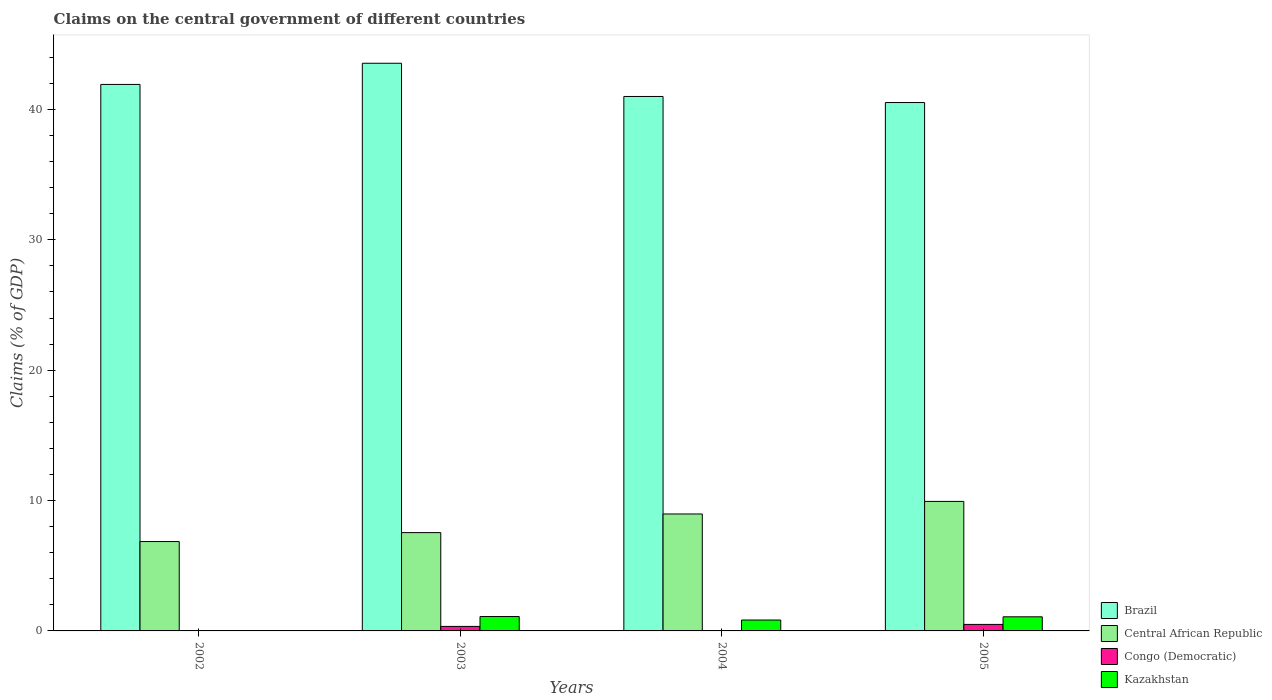How many groups of bars are there?
Your answer should be very brief. 4. Are the number of bars per tick equal to the number of legend labels?
Make the answer very short. No. How many bars are there on the 3rd tick from the right?
Provide a short and direct response. 4. What is the percentage of GDP claimed on the central government in Brazil in 2005?
Offer a very short reply. 40.53. Across all years, what is the maximum percentage of GDP claimed on the central government in Central African Republic?
Your response must be concise. 9.93. Across all years, what is the minimum percentage of GDP claimed on the central government in Central African Republic?
Keep it short and to the point. 6.86. In which year was the percentage of GDP claimed on the central government in Congo (Democratic) maximum?
Provide a succinct answer. 2005. What is the total percentage of GDP claimed on the central government in Central African Republic in the graph?
Give a very brief answer. 33.3. What is the difference between the percentage of GDP claimed on the central government in Brazil in 2002 and that in 2005?
Your answer should be very brief. 1.39. What is the difference between the percentage of GDP claimed on the central government in Congo (Democratic) in 2002 and the percentage of GDP claimed on the central government in Central African Republic in 2004?
Provide a short and direct response. -8.97. What is the average percentage of GDP claimed on the central government in Kazakhstan per year?
Give a very brief answer. 0.76. In the year 2005, what is the difference between the percentage of GDP claimed on the central government in Congo (Democratic) and percentage of GDP claimed on the central government in Kazakhstan?
Provide a succinct answer. -0.58. What is the ratio of the percentage of GDP claimed on the central government in Kazakhstan in 2003 to that in 2005?
Ensure brevity in your answer.  1.02. What is the difference between the highest and the second highest percentage of GDP claimed on the central government in Brazil?
Offer a very short reply. 1.62. What is the difference between the highest and the lowest percentage of GDP claimed on the central government in Brazil?
Your answer should be compact. 3.01. In how many years, is the percentage of GDP claimed on the central government in Congo (Democratic) greater than the average percentage of GDP claimed on the central government in Congo (Democratic) taken over all years?
Your response must be concise. 2. Is the sum of the percentage of GDP claimed on the central government in Central African Republic in 2003 and 2005 greater than the maximum percentage of GDP claimed on the central government in Congo (Democratic) across all years?
Offer a very short reply. Yes. Is it the case that in every year, the sum of the percentage of GDP claimed on the central government in Brazil and percentage of GDP claimed on the central government in Kazakhstan is greater than the sum of percentage of GDP claimed on the central government in Congo (Democratic) and percentage of GDP claimed on the central government in Central African Republic?
Your response must be concise. Yes. Is it the case that in every year, the sum of the percentage of GDP claimed on the central government in Central African Republic and percentage of GDP claimed on the central government in Congo (Democratic) is greater than the percentage of GDP claimed on the central government in Kazakhstan?
Your response must be concise. Yes. How many years are there in the graph?
Offer a terse response. 4. What is the difference between two consecutive major ticks on the Y-axis?
Provide a short and direct response. 10. Does the graph contain any zero values?
Provide a succinct answer. Yes. How many legend labels are there?
Your response must be concise. 4. How are the legend labels stacked?
Provide a short and direct response. Vertical. What is the title of the graph?
Offer a very short reply. Claims on the central government of different countries. Does "Samoa" appear as one of the legend labels in the graph?
Ensure brevity in your answer.  No. What is the label or title of the X-axis?
Your response must be concise. Years. What is the label or title of the Y-axis?
Your answer should be very brief. Claims (% of GDP). What is the Claims (% of GDP) of Brazil in 2002?
Keep it short and to the point. 41.92. What is the Claims (% of GDP) of Central African Republic in 2002?
Your answer should be very brief. 6.86. What is the Claims (% of GDP) of Kazakhstan in 2002?
Provide a short and direct response. 0. What is the Claims (% of GDP) in Brazil in 2003?
Make the answer very short. 43.54. What is the Claims (% of GDP) of Central African Republic in 2003?
Offer a very short reply. 7.54. What is the Claims (% of GDP) in Congo (Democratic) in 2003?
Offer a terse response. 0.35. What is the Claims (% of GDP) of Kazakhstan in 2003?
Your answer should be compact. 1.1. What is the Claims (% of GDP) in Brazil in 2004?
Offer a very short reply. 40.99. What is the Claims (% of GDP) of Central African Republic in 2004?
Offer a very short reply. 8.97. What is the Claims (% of GDP) of Congo (Democratic) in 2004?
Give a very brief answer. 0. What is the Claims (% of GDP) in Kazakhstan in 2004?
Your answer should be compact. 0.84. What is the Claims (% of GDP) in Brazil in 2005?
Ensure brevity in your answer.  40.53. What is the Claims (% of GDP) of Central African Republic in 2005?
Ensure brevity in your answer.  9.93. What is the Claims (% of GDP) in Congo (Democratic) in 2005?
Give a very brief answer. 0.5. What is the Claims (% of GDP) in Kazakhstan in 2005?
Your answer should be compact. 1.08. Across all years, what is the maximum Claims (% of GDP) in Brazil?
Your answer should be compact. 43.54. Across all years, what is the maximum Claims (% of GDP) in Central African Republic?
Provide a short and direct response. 9.93. Across all years, what is the maximum Claims (% of GDP) of Congo (Democratic)?
Your answer should be very brief. 0.5. Across all years, what is the maximum Claims (% of GDP) in Kazakhstan?
Make the answer very short. 1.1. Across all years, what is the minimum Claims (% of GDP) of Brazil?
Your answer should be very brief. 40.53. Across all years, what is the minimum Claims (% of GDP) of Central African Republic?
Offer a very short reply. 6.86. Across all years, what is the minimum Claims (% of GDP) in Kazakhstan?
Ensure brevity in your answer.  0. What is the total Claims (% of GDP) of Brazil in the graph?
Ensure brevity in your answer.  166.98. What is the total Claims (% of GDP) of Central African Republic in the graph?
Make the answer very short. 33.3. What is the total Claims (% of GDP) in Congo (Democratic) in the graph?
Give a very brief answer. 0.85. What is the total Claims (% of GDP) of Kazakhstan in the graph?
Offer a very short reply. 3.02. What is the difference between the Claims (% of GDP) in Brazil in 2002 and that in 2003?
Provide a succinct answer. -1.62. What is the difference between the Claims (% of GDP) of Central African Republic in 2002 and that in 2003?
Provide a short and direct response. -0.68. What is the difference between the Claims (% of GDP) of Brazil in 2002 and that in 2004?
Ensure brevity in your answer.  0.92. What is the difference between the Claims (% of GDP) in Central African Republic in 2002 and that in 2004?
Your answer should be compact. -2.12. What is the difference between the Claims (% of GDP) in Brazil in 2002 and that in 2005?
Ensure brevity in your answer.  1.39. What is the difference between the Claims (% of GDP) of Central African Republic in 2002 and that in 2005?
Give a very brief answer. -3.08. What is the difference between the Claims (% of GDP) in Brazil in 2003 and that in 2004?
Make the answer very short. 2.55. What is the difference between the Claims (% of GDP) in Central African Republic in 2003 and that in 2004?
Give a very brief answer. -1.43. What is the difference between the Claims (% of GDP) in Kazakhstan in 2003 and that in 2004?
Offer a terse response. 0.27. What is the difference between the Claims (% of GDP) in Brazil in 2003 and that in 2005?
Your answer should be compact. 3.01. What is the difference between the Claims (% of GDP) of Central African Republic in 2003 and that in 2005?
Keep it short and to the point. -2.39. What is the difference between the Claims (% of GDP) in Congo (Democratic) in 2003 and that in 2005?
Provide a succinct answer. -0.15. What is the difference between the Claims (% of GDP) of Kazakhstan in 2003 and that in 2005?
Your response must be concise. 0.02. What is the difference between the Claims (% of GDP) of Brazil in 2004 and that in 2005?
Your answer should be very brief. 0.47. What is the difference between the Claims (% of GDP) of Central African Republic in 2004 and that in 2005?
Keep it short and to the point. -0.96. What is the difference between the Claims (% of GDP) of Kazakhstan in 2004 and that in 2005?
Provide a succinct answer. -0.25. What is the difference between the Claims (% of GDP) in Brazil in 2002 and the Claims (% of GDP) in Central African Republic in 2003?
Keep it short and to the point. 34.38. What is the difference between the Claims (% of GDP) of Brazil in 2002 and the Claims (% of GDP) of Congo (Democratic) in 2003?
Provide a short and direct response. 41.57. What is the difference between the Claims (% of GDP) of Brazil in 2002 and the Claims (% of GDP) of Kazakhstan in 2003?
Give a very brief answer. 40.82. What is the difference between the Claims (% of GDP) of Central African Republic in 2002 and the Claims (% of GDP) of Congo (Democratic) in 2003?
Make the answer very short. 6.51. What is the difference between the Claims (% of GDP) in Central African Republic in 2002 and the Claims (% of GDP) in Kazakhstan in 2003?
Give a very brief answer. 5.75. What is the difference between the Claims (% of GDP) of Brazil in 2002 and the Claims (% of GDP) of Central African Republic in 2004?
Give a very brief answer. 32.95. What is the difference between the Claims (% of GDP) in Brazil in 2002 and the Claims (% of GDP) in Kazakhstan in 2004?
Your answer should be compact. 41.08. What is the difference between the Claims (% of GDP) in Central African Republic in 2002 and the Claims (% of GDP) in Kazakhstan in 2004?
Make the answer very short. 6.02. What is the difference between the Claims (% of GDP) of Brazil in 2002 and the Claims (% of GDP) of Central African Republic in 2005?
Give a very brief answer. 31.98. What is the difference between the Claims (% of GDP) of Brazil in 2002 and the Claims (% of GDP) of Congo (Democratic) in 2005?
Offer a terse response. 41.42. What is the difference between the Claims (% of GDP) of Brazil in 2002 and the Claims (% of GDP) of Kazakhstan in 2005?
Your answer should be compact. 40.84. What is the difference between the Claims (% of GDP) in Central African Republic in 2002 and the Claims (% of GDP) in Congo (Democratic) in 2005?
Offer a very short reply. 6.36. What is the difference between the Claims (% of GDP) in Central African Republic in 2002 and the Claims (% of GDP) in Kazakhstan in 2005?
Your answer should be compact. 5.77. What is the difference between the Claims (% of GDP) in Brazil in 2003 and the Claims (% of GDP) in Central African Republic in 2004?
Your answer should be very brief. 34.57. What is the difference between the Claims (% of GDP) of Brazil in 2003 and the Claims (% of GDP) of Kazakhstan in 2004?
Your answer should be very brief. 42.71. What is the difference between the Claims (% of GDP) of Central African Republic in 2003 and the Claims (% of GDP) of Kazakhstan in 2004?
Offer a very short reply. 6.7. What is the difference between the Claims (% of GDP) in Congo (Democratic) in 2003 and the Claims (% of GDP) in Kazakhstan in 2004?
Ensure brevity in your answer.  -0.49. What is the difference between the Claims (% of GDP) in Brazil in 2003 and the Claims (% of GDP) in Central African Republic in 2005?
Your response must be concise. 33.61. What is the difference between the Claims (% of GDP) of Brazil in 2003 and the Claims (% of GDP) of Congo (Democratic) in 2005?
Offer a terse response. 43.04. What is the difference between the Claims (% of GDP) in Brazil in 2003 and the Claims (% of GDP) in Kazakhstan in 2005?
Keep it short and to the point. 42.46. What is the difference between the Claims (% of GDP) of Central African Republic in 2003 and the Claims (% of GDP) of Congo (Democratic) in 2005?
Provide a succinct answer. 7.04. What is the difference between the Claims (% of GDP) of Central African Republic in 2003 and the Claims (% of GDP) of Kazakhstan in 2005?
Offer a very short reply. 6.46. What is the difference between the Claims (% of GDP) of Congo (Democratic) in 2003 and the Claims (% of GDP) of Kazakhstan in 2005?
Offer a very short reply. -0.74. What is the difference between the Claims (% of GDP) in Brazil in 2004 and the Claims (% of GDP) in Central African Republic in 2005?
Ensure brevity in your answer.  31.06. What is the difference between the Claims (% of GDP) in Brazil in 2004 and the Claims (% of GDP) in Congo (Democratic) in 2005?
Offer a terse response. 40.49. What is the difference between the Claims (% of GDP) in Brazil in 2004 and the Claims (% of GDP) in Kazakhstan in 2005?
Offer a very short reply. 39.91. What is the difference between the Claims (% of GDP) in Central African Republic in 2004 and the Claims (% of GDP) in Congo (Democratic) in 2005?
Your answer should be compact. 8.47. What is the difference between the Claims (% of GDP) in Central African Republic in 2004 and the Claims (% of GDP) in Kazakhstan in 2005?
Ensure brevity in your answer.  7.89. What is the average Claims (% of GDP) in Brazil per year?
Provide a short and direct response. 41.75. What is the average Claims (% of GDP) of Central African Republic per year?
Give a very brief answer. 8.32. What is the average Claims (% of GDP) in Congo (Democratic) per year?
Keep it short and to the point. 0.21. What is the average Claims (% of GDP) of Kazakhstan per year?
Provide a succinct answer. 0.76. In the year 2002, what is the difference between the Claims (% of GDP) in Brazil and Claims (% of GDP) in Central African Republic?
Your answer should be compact. 35.06. In the year 2003, what is the difference between the Claims (% of GDP) of Brazil and Claims (% of GDP) of Central African Republic?
Provide a short and direct response. 36. In the year 2003, what is the difference between the Claims (% of GDP) in Brazil and Claims (% of GDP) in Congo (Democratic)?
Ensure brevity in your answer.  43.2. In the year 2003, what is the difference between the Claims (% of GDP) of Brazil and Claims (% of GDP) of Kazakhstan?
Keep it short and to the point. 42.44. In the year 2003, what is the difference between the Claims (% of GDP) in Central African Republic and Claims (% of GDP) in Congo (Democratic)?
Ensure brevity in your answer.  7.19. In the year 2003, what is the difference between the Claims (% of GDP) of Central African Republic and Claims (% of GDP) of Kazakhstan?
Offer a very short reply. 6.44. In the year 2003, what is the difference between the Claims (% of GDP) of Congo (Democratic) and Claims (% of GDP) of Kazakhstan?
Provide a succinct answer. -0.76. In the year 2004, what is the difference between the Claims (% of GDP) of Brazil and Claims (% of GDP) of Central African Republic?
Provide a short and direct response. 32.02. In the year 2004, what is the difference between the Claims (% of GDP) in Brazil and Claims (% of GDP) in Kazakhstan?
Offer a terse response. 40.16. In the year 2004, what is the difference between the Claims (% of GDP) in Central African Republic and Claims (% of GDP) in Kazakhstan?
Give a very brief answer. 8.13. In the year 2005, what is the difference between the Claims (% of GDP) in Brazil and Claims (% of GDP) in Central African Republic?
Provide a short and direct response. 30.6. In the year 2005, what is the difference between the Claims (% of GDP) of Brazil and Claims (% of GDP) of Congo (Democratic)?
Provide a succinct answer. 40.03. In the year 2005, what is the difference between the Claims (% of GDP) of Brazil and Claims (% of GDP) of Kazakhstan?
Your answer should be compact. 39.45. In the year 2005, what is the difference between the Claims (% of GDP) in Central African Republic and Claims (% of GDP) in Congo (Democratic)?
Your answer should be compact. 9.43. In the year 2005, what is the difference between the Claims (% of GDP) in Central African Republic and Claims (% of GDP) in Kazakhstan?
Offer a very short reply. 8.85. In the year 2005, what is the difference between the Claims (% of GDP) of Congo (Democratic) and Claims (% of GDP) of Kazakhstan?
Your response must be concise. -0.58. What is the ratio of the Claims (% of GDP) of Brazil in 2002 to that in 2003?
Your answer should be compact. 0.96. What is the ratio of the Claims (% of GDP) of Central African Republic in 2002 to that in 2003?
Provide a short and direct response. 0.91. What is the ratio of the Claims (% of GDP) in Brazil in 2002 to that in 2004?
Make the answer very short. 1.02. What is the ratio of the Claims (% of GDP) in Central African Republic in 2002 to that in 2004?
Your answer should be very brief. 0.76. What is the ratio of the Claims (% of GDP) in Brazil in 2002 to that in 2005?
Your answer should be very brief. 1.03. What is the ratio of the Claims (% of GDP) in Central African Republic in 2002 to that in 2005?
Make the answer very short. 0.69. What is the ratio of the Claims (% of GDP) of Brazil in 2003 to that in 2004?
Provide a short and direct response. 1.06. What is the ratio of the Claims (% of GDP) of Central African Republic in 2003 to that in 2004?
Keep it short and to the point. 0.84. What is the ratio of the Claims (% of GDP) of Kazakhstan in 2003 to that in 2004?
Offer a terse response. 1.32. What is the ratio of the Claims (% of GDP) in Brazil in 2003 to that in 2005?
Provide a short and direct response. 1.07. What is the ratio of the Claims (% of GDP) in Central African Republic in 2003 to that in 2005?
Provide a succinct answer. 0.76. What is the ratio of the Claims (% of GDP) of Congo (Democratic) in 2003 to that in 2005?
Provide a succinct answer. 0.69. What is the ratio of the Claims (% of GDP) of Kazakhstan in 2003 to that in 2005?
Your answer should be very brief. 1.02. What is the ratio of the Claims (% of GDP) in Brazil in 2004 to that in 2005?
Ensure brevity in your answer.  1.01. What is the ratio of the Claims (% of GDP) in Central African Republic in 2004 to that in 2005?
Your answer should be compact. 0.9. What is the ratio of the Claims (% of GDP) of Kazakhstan in 2004 to that in 2005?
Offer a terse response. 0.77. What is the difference between the highest and the second highest Claims (% of GDP) in Brazil?
Offer a terse response. 1.62. What is the difference between the highest and the second highest Claims (% of GDP) in Central African Republic?
Ensure brevity in your answer.  0.96. What is the difference between the highest and the second highest Claims (% of GDP) of Kazakhstan?
Keep it short and to the point. 0.02. What is the difference between the highest and the lowest Claims (% of GDP) in Brazil?
Give a very brief answer. 3.01. What is the difference between the highest and the lowest Claims (% of GDP) in Central African Republic?
Make the answer very short. 3.08. What is the difference between the highest and the lowest Claims (% of GDP) in Congo (Democratic)?
Offer a terse response. 0.5. What is the difference between the highest and the lowest Claims (% of GDP) in Kazakhstan?
Your answer should be very brief. 1.1. 